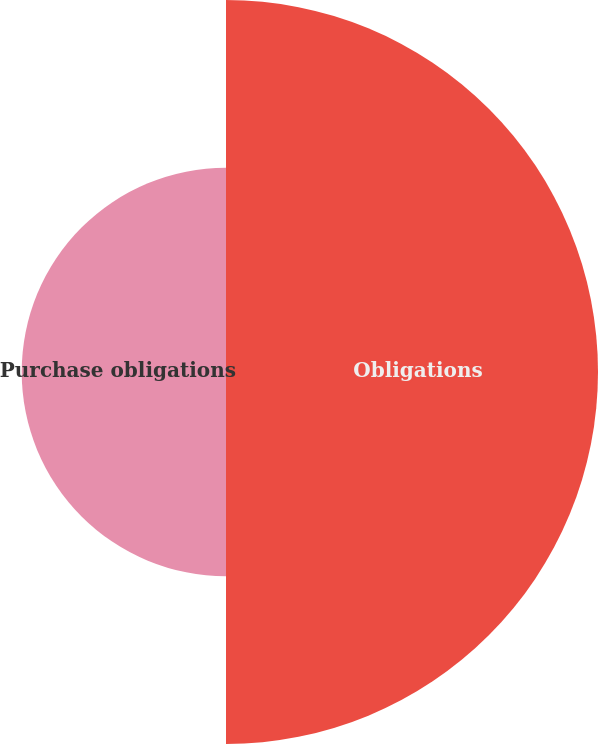<chart> <loc_0><loc_0><loc_500><loc_500><pie_chart><fcel>Obligations<fcel>Purchase obligations<nl><fcel>64.55%<fcel>35.45%<nl></chart> 